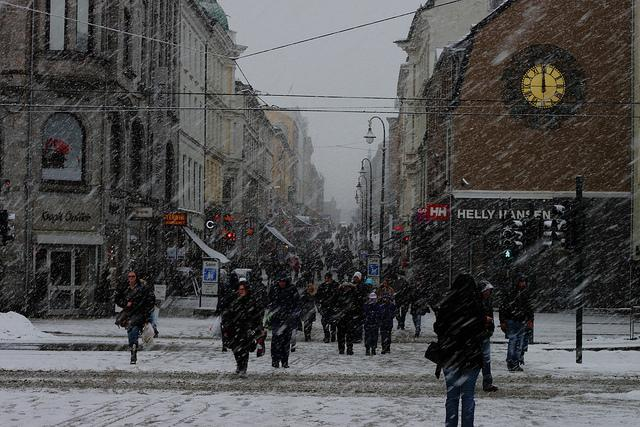What is the composition of the falling material? snow 